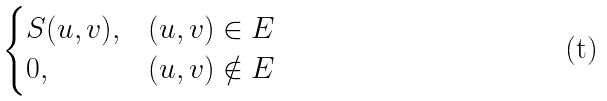<formula> <loc_0><loc_0><loc_500><loc_500>\begin{cases} S ( u , v ) , & ( u , v ) \in E \\ 0 , & ( u , v ) \notin E \end{cases}</formula> 